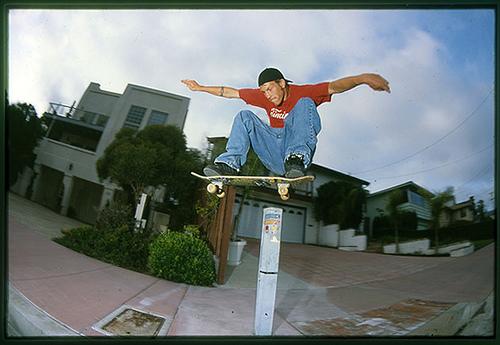What is he jumping over?
Keep it brief. Pole. Is this a recent photo?
Be succinct. Yes. What color is the man's shirt?
Write a very short answer. Red. Is the sky clear?
Give a very brief answer. No. What color is the skateboard?
Keep it brief. White. Is parking allowed in this area?
Keep it brief. No. Is he a good skater?
Concise answer only. Yes. What is the man jumping over?
Keep it brief. Post. Is this a street or alley?
Give a very brief answer. Street. What board is this?
Answer briefly. Skateboard. What sport is this?
Keep it brief. Skateboarding. How many pieces of sports equipment are featured in the picture?
Be succinct. 1. Is this a modern day picture?
Concise answer only. Yes. What color is the pole?
Short answer required. Gray. What color is the man's hat?
Give a very brief answer. Black. Where are these kids skateboarding?
Give a very brief answer. Sidewalk. What color are the men's shoes who is jumping with the skateboard?
Answer briefly. Black. Does he look like he will land on his skateboard?
Keep it brief. Yes. Is this an old picture?
Keep it brief. Yes. Is the skateboarder doing the trick coming up or going down?
Quick response, please. Down. 